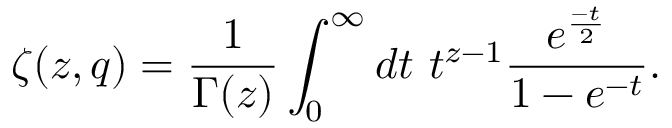<formula> <loc_0><loc_0><loc_500><loc_500>\zeta ( z , q ) = \frac { 1 } { \Gamma ( z ) } \int _ { 0 } ^ { \infty } d t t ^ { z - 1 } \frac { e ^ { \frac { - t } { 2 } } } { 1 - e ^ { - t } } .</formula> 